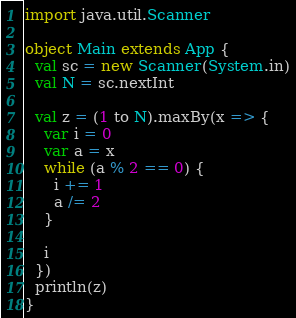<code> <loc_0><loc_0><loc_500><loc_500><_Scala_>import java.util.Scanner

object Main extends App {
  val sc = new Scanner(System.in)
  val N = sc.nextInt

  val z = (1 to N).maxBy(x => {
    var i = 0
    var a = x
    while (a % 2 == 0) {
      i += 1
      a /= 2
    }

    i
  })
  println(z)
}
</code> 